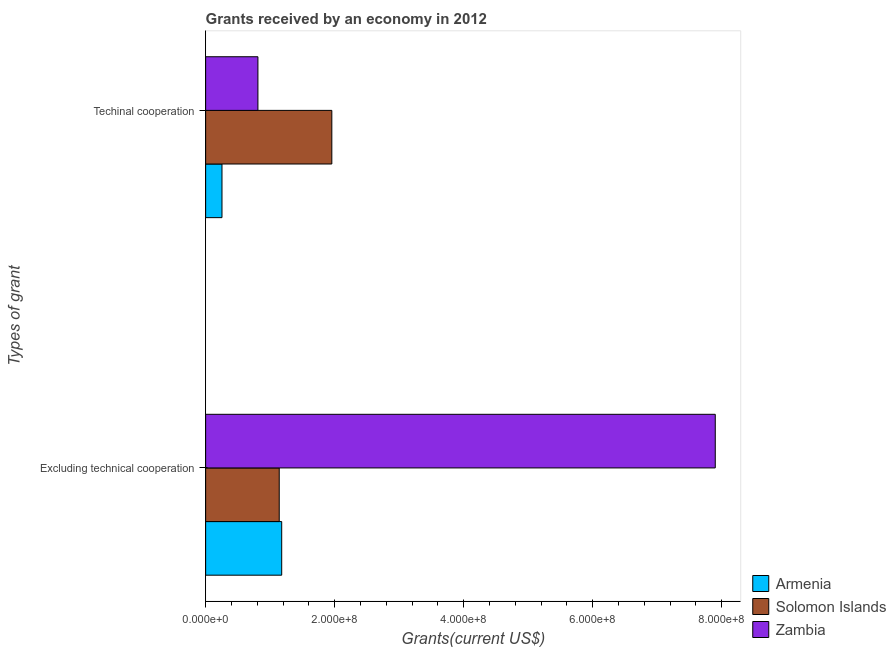How many groups of bars are there?
Your response must be concise. 2. How many bars are there on the 1st tick from the top?
Ensure brevity in your answer.  3. What is the label of the 1st group of bars from the top?
Provide a short and direct response. Techinal cooperation. What is the amount of grants received(excluding technical cooperation) in Zambia?
Give a very brief answer. 7.90e+08. Across all countries, what is the maximum amount of grants received(excluding technical cooperation)?
Provide a succinct answer. 7.90e+08. Across all countries, what is the minimum amount of grants received(excluding technical cooperation)?
Your answer should be very brief. 1.14e+08. In which country was the amount of grants received(excluding technical cooperation) maximum?
Offer a terse response. Zambia. In which country was the amount of grants received(excluding technical cooperation) minimum?
Ensure brevity in your answer.  Solomon Islands. What is the total amount of grants received(including technical cooperation) in the graph?
Keep it short and to the point. 3.02e+08. What is the difference between the amount of grants received(including technical cooperation) in Armenia and that in Zambia?
Your response must be concise. -5.57e+07. What is the difference between the amount of grants received(excluding technical cooperation) in Solomon Islands and the amount of grants received(including technical cooperation) in Armenia?
Keep it short and to the point. 8.88e+07. What is the average amount of grants received(excluding technical cooperation) per country?
Offer a very short reply. 3.41e+08. What is the difference between the amount of grants received(excluding technical cooperation) and amount of grants received(including technical cooperation) in Zambia?
Your answer should be very brief. 7.09e+08. In how many countries, is the amount of grants received(including technical cooperation) greater than 40000000 US$?
Keep it short and to the point. 2. What is the ratio of the amount of grants received(excluding technical cooperation) in Solomon Islands to that in Armenia?
Provide a succinct answer. 0.97. What does the 2nd bar from the top in Techinal cooperation represents?
Your answer should be compact. Solomon Islands. What does the 3rd bar from the bottom in Excluding technical cooperation represents?
Your answer should be very brief. Zambia. How many bars are there?
Ensure brevity in your answer.  6. How many countries are there in the graph?
Make the answer very short. 3. Are the values on the major ticks of X-axis written in scientific E-notation?
Provide a short and direct response. Yes. How many legend labels are there?
Your answer should be compact. 3. How are the legend labels stacked?
Ensure brevity in your answer.  Vertical. What is the title of the graph?
Ensure brevity in your answer.  Grants received by an economy in 2012. Does "Italy" appear as one of the legend labels in the graph?
Keep it short and to the point. No. What is the label or title of the X-axis?
Provide a succinct answer. Grants(current US$). What is the label or title of the Y-axis?
Provide a succinct answer. Types of grant. What is the Grants(current US$) in Armenia in Excluding technical cooperation?
Your answer should be compact. 1.18e+08. What is the Grants(current US$) in Solomon Islands in Excluding technical cooperation?
Provide a succinct answer. 1.14e+08. What is the Grants(current US$) in Zambia in Excluding technical cooperation?
Keep it short and to the point. 7.90e+08. What is the Grants(current US$) of Armenia in Techinal cooperation?
Make the answer very short. 2.53e+07. What is the Grants(current US$) of Solomon Islands in Techinal cooperation?
Your answer should be very brief. 1.96e+08. What is the Grants(current US$) in Zambia in Techinal cooperation?
Provide a succinct answer. 8.10e+07. Across all Types of grant, what is the maximum Grants(current US$) in Armenia?
Ensure brevity in your answer.  1.18e+08. Across all Types of grant, what is the maximum Grants(current US$) of Solomon Islands?
Provide a short and direct response. 1.96e+08. Across all Types of grant, what is the maximum Grants(current US$) of Zambia?
Ensure brevity in your answer.  7.90e+08. Across all Types of grant, what is the minimum Grants(current US$) in Armenia?
Offer a terse response. 2.53e+07. Across all Types of grant, what is the minimum Grants(current US$) in Solomon Islands?
Your answer should be compact. 1.14e+08. Across all Types of grant, what is the minimum Grants(current US$) of Zambia?
Ensure brevity in your answer.  8.10e+07. What is the total Grants(current US$) in Armenia in the graph?
Offer a very short reply. 1.43e+08. What is the total Grants(current US$) in Solomon Islands in the graph?
Ensure brevity in your answer.  3.10e+08. What is the total Grants(current US$) in Zambia in the graph?
Offer a very short reply. 8.71e+08. What is the difference between the Grants(current US$) of Armenia in Excluding technical cooperation and that in Techinal cooperation?
Ensure brevity in your answer.  9.26e+07. What is the difference between the Grants(current US$) of Solomon Islands in Excluding technical cooperation and that in Techinal cooperation?
Make the answer very short. -8.15e+07. What is the difference between the Grants(current US$) in Zambia in Excluding technical cooperation and that in Techinal cooperation?
Offer a very short reply. 7.09e+08. What is the difference between the Grants(current US$) in Armenia in Excluding technical cooperation and the Grants(current US$) in Solomon Islands in Techinal cooperation?
Your answer should be very brief. -7.77e+07. What is the difference between the Grants(current US$) of Armenia in Excluding technical cooperation and the Grants(current US$) of Zambia in Techinal cooperation?
Offer a terse response. 3.68e+07. What is the difference between the Grants(current US$) of Solomon Islands in Excluding technical cooperation and the Grants(current US$) of Zambia in Techinal cooperation?
Your answer should be compact. 3.30e+07. What is the average Grants(current US$) of Armenia per Types of grant?
Offer a very short reply. 7.16e+07. What is the average Grants(current US$) in Solomon Islands per Types of grant?
Provide a short and direct response. 1.55e+08. What is the average Grants(current US$) of Zambia per Types of grant?
Make the answer very short. 4.35e+08. What is the difference between the Grants(current US$) of Armenia and Grants(current US$) of Solomon Islands in Excluding technical cooperation?
Provide a short and direct response. 3.81e+06. What is the difference between the Grants(current US$) of Armenia and Grants(current US$) of Zambia in Excluding technical cooperation?
Ensure brevity in your answer.  -6.72e+08. What is the difference between the Grants(current US$) in Solomon Islands and Grants(current US$) in Zambia in Excluding technical cooperation?
Keep it short and to the point. -6.76e+08. What is the difference between the Grants(current US$) in Armenia and Grants(current US$) in Solomon Islands in Techinal cooperation?
Offer a very short reply. -1.70e+08. What is the difference between the Grants(current US$) in Armenia and Grants(current US$) in Zambia in Techinal cooperation?
Keep it short and to the point. -5.57e+07. What is the difference between the Grants(current US$) of Solomon Islands and Grants(current US$) of Zambia in Techinal cooperation?
Provide a short and direct response. 1.15e+08. What is the ratio of the Grants(current US$) in Armenia in Excluding technical cooperation to that in Techinal cooperation?
Offer a terse response. 4.65. What is the ratio of the Grants(current US$) in Solomon Islands in Excluding technical cooperation to that in Techinal cooperation?
Offer a very short reply. 0.58. What is the ratio of the Grants(current US$) in Zambia in Excluding technical cooperation to that in Techinal cooperation?
Offer a very short reply. 9.75. What is the difference between the highest and the second highest Grants(current US$) of Armenia?
Provide a short and direct response. 9.26e+07. What is the difference between the highest and the second highest Grants(current US$) of Solomon Islands?
Your answer should be compact. 8.15e+07. What is the difference between the highest and the second highest Grants(current US$) in Zambia?
Your response must be concise. 7.09e+08. What is the difference between the highest and the lowest Grants(current US$) of Armenia?
Offer a terse response. 9.26e+07. What is the difference between the highest and the lowest Grants(current US$) in Solomon Islands?
Provide a short and direct response. 8.15e+07. What is the difference between the highest and the lowest Grants(current US$) of Zambia?
Offer a very short reply. 7.09e+08. 